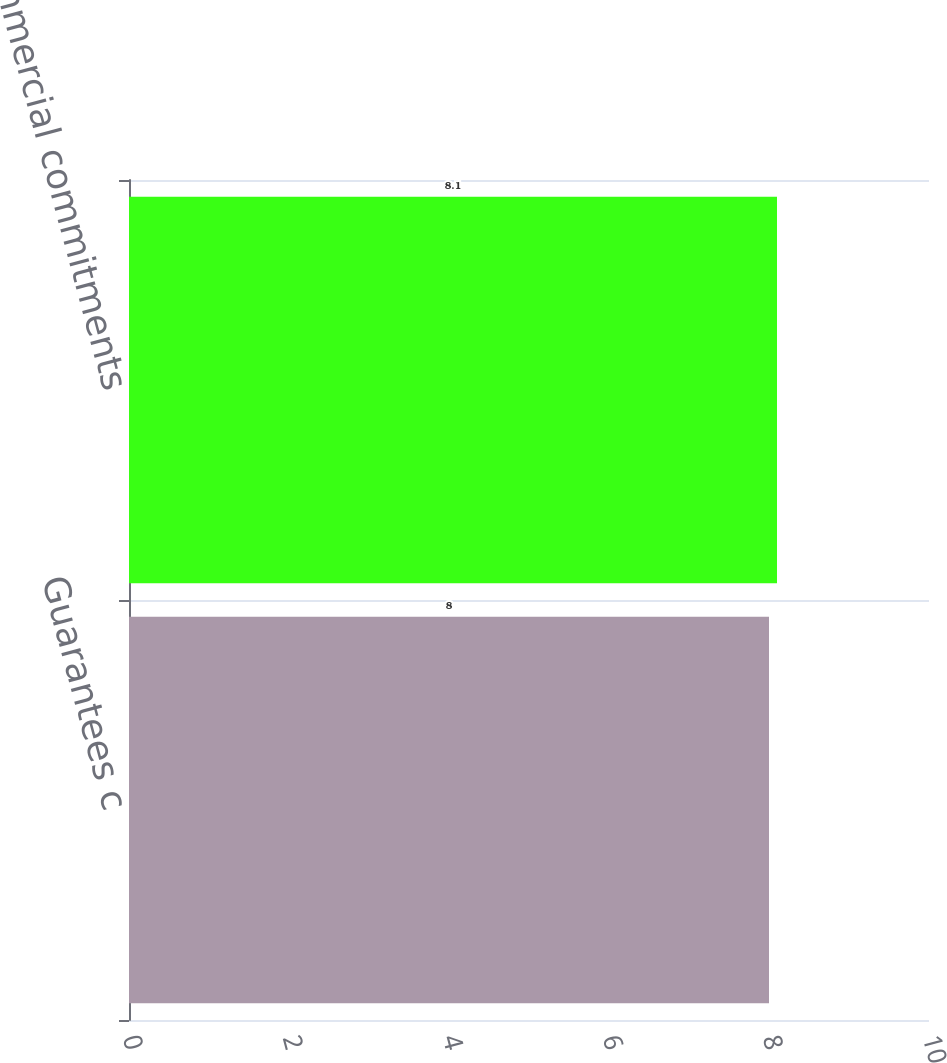Convert chart to OTSL. <chart><loc_0><loc_0><loc_500><loc_500><bar_chart><fcel>Guarantees c<fcel>Total commercial commitments<nl><fcel>8<fcel>8.1<nl></chart> 